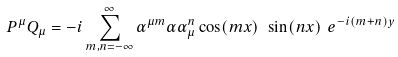Convert formula to latex. <formula><loc_0><loc_0><loc_500><loc_500>P ^ { \mu } Q _ { \mu } = - i \sum _ { m , n = - \infty } ^ { \infty } \alpha ^ { \mu m } \alpha \alpha _ { \mu } ^ { n } \cos ( m x ) \ \sin ( n x ) \ e ^ { - i ( m + n ) y }</formula> 